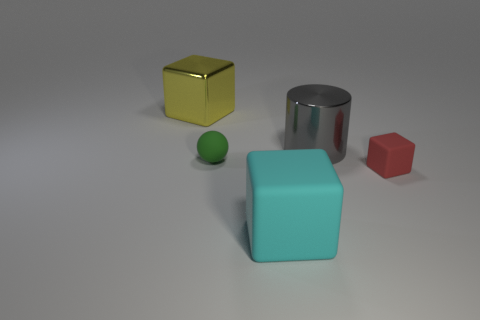What material is the yellow thing that is the same size as the gray shiny thing?
Give a very brief answer. Metal. How many objects are large yellow rubber cylinders or large metallic objects behind the gray metallic thing?
Provide a short and direct response. 1. There is a red block that is made of the same material as the small green object; what size is it?
Provide a short and direct response. Small. The big cyan rubber thing that is in front of the big shiny thing that is to the right of the metallic cube is what shape?
Offer a terse response. Cube. What is the size of the matte thing that is both behind the big rubber cube and left of the red block?
Give a very brief answer. Small. Is there a tiny red thing of the same shape as the large yellow metallic object?
Make the answer very short. Yes. Is there anything else that is the same shape as the green rubber thing?
Offer a very short reply. No. The block behind the block right of the big metallic thing that is in front of the big yellow thing is made of what material?
Keep it short and to the point. Metal. Are there any things that have the same size as the cyan cube?
Provide a succinct answer. Yes. There is a matte thing that is left of the large cyan rubber cube in front of the sphere; what is its color?
Give a very brief answer. Green. 